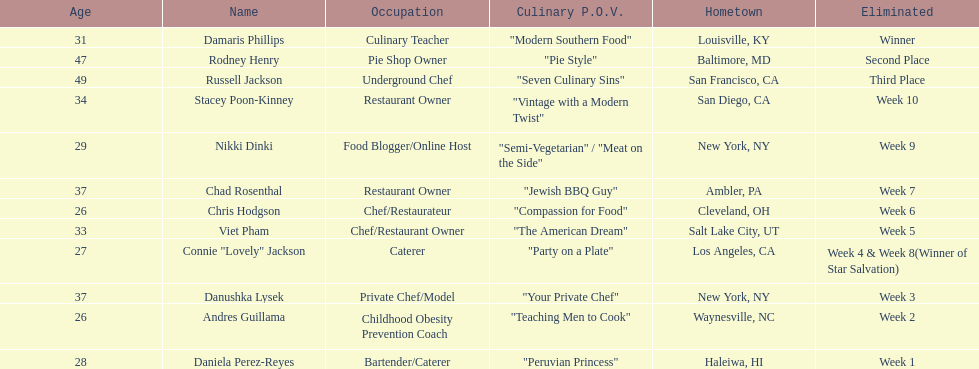Whose culinary perspective was described more extensively than "vintage with a modern twist" among the contestants? Nikki Dinki. 